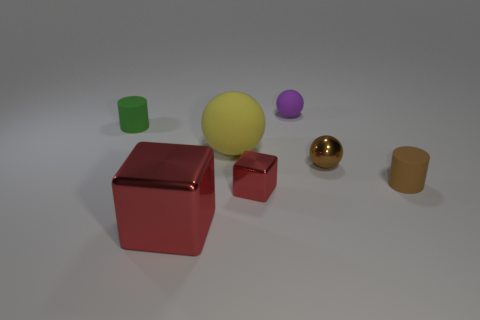Subtract all rubber balls. How many balls are left? 1 Add 1 brown rubber things. How many objects exist? 8 Subtract all balls. How many objects are left? 4 Subtract all brown balls. How many balls are left? 2 Subtract 2 balls. How many balls are left? 1 Subtract all red spheres. Subtract all red cylinders. How many spheres are left? 3 Subtract all green cylinders. How many yellow spheres are left? 1 Subtract all rubber things. Subtract all big shiny objects. How many objects are left? 2 Add 7 tiny matte cylinders. How many tiny matte cylinders are left? 9 Add 3 small brown matte cylinders. How many small brown matte cylinders exist? 4 